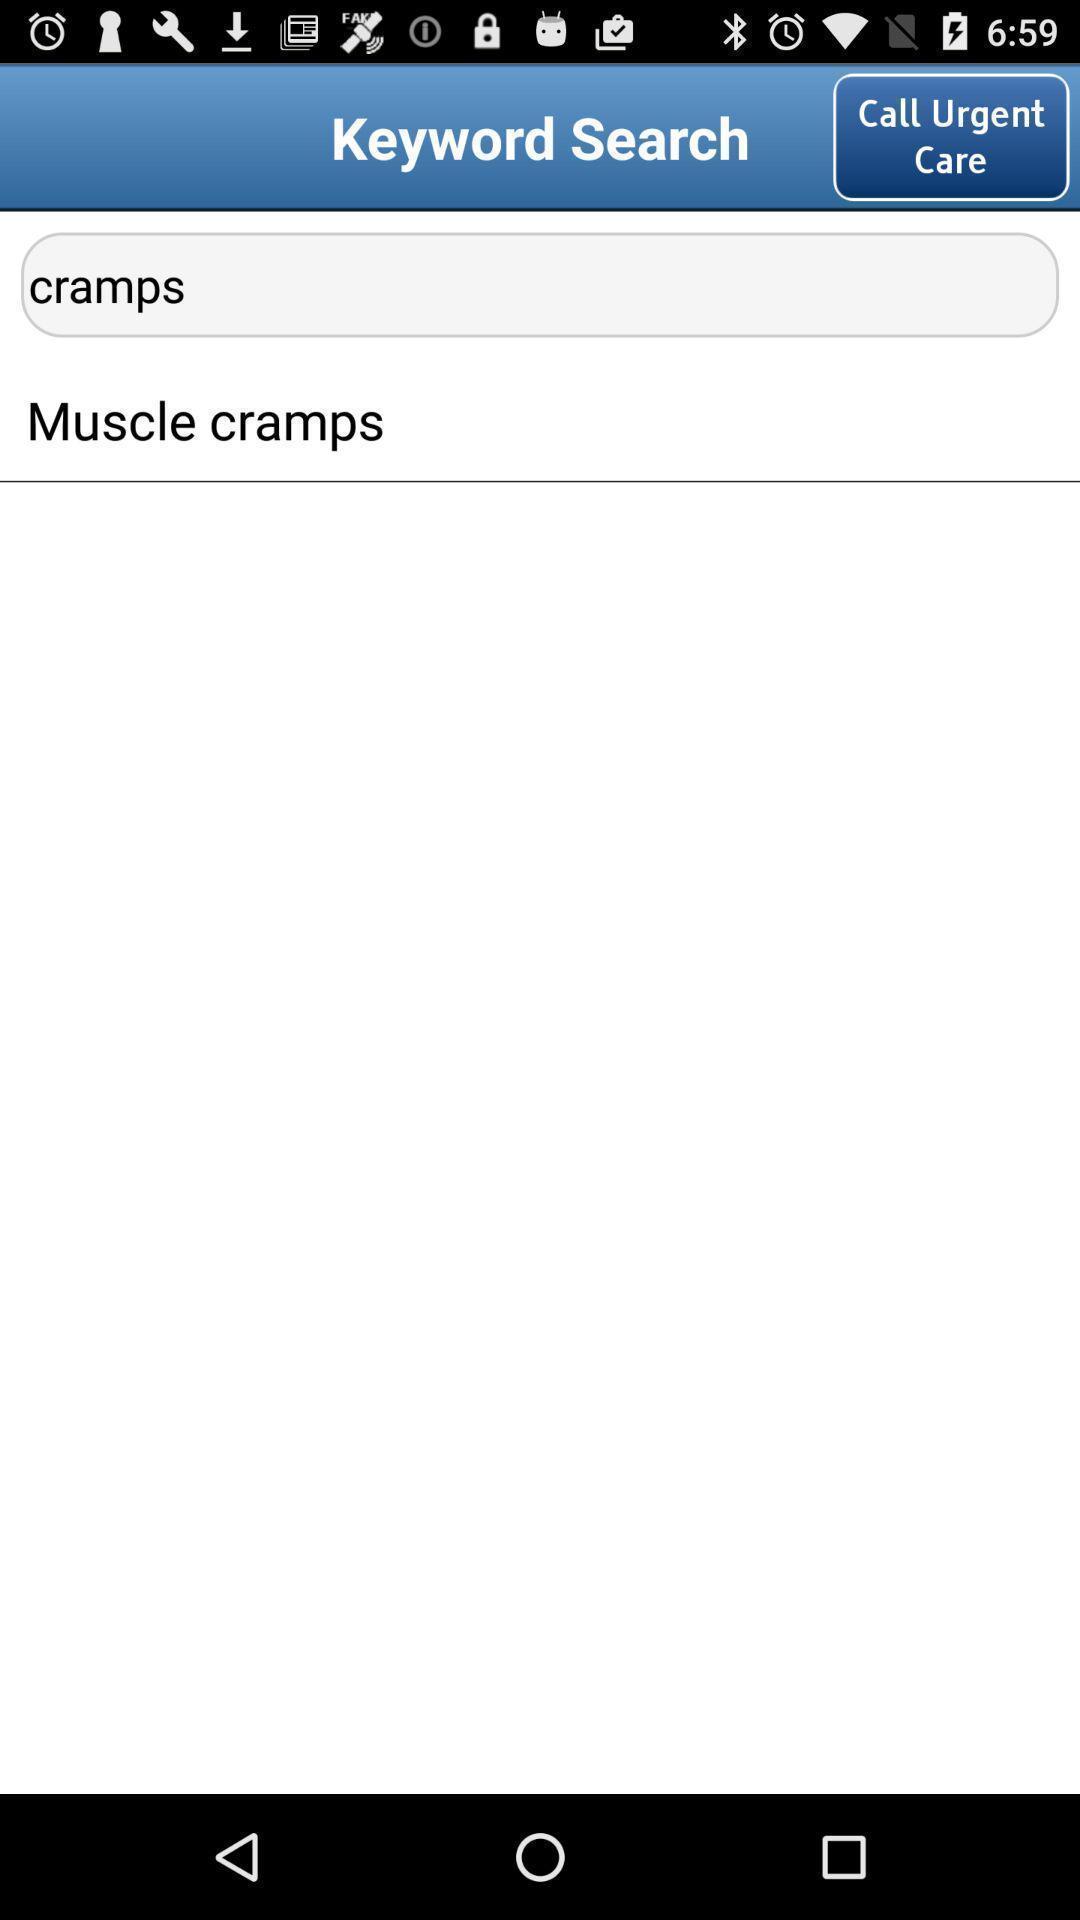Explain what's happening in this screen capture. Search page of a browsing app. 